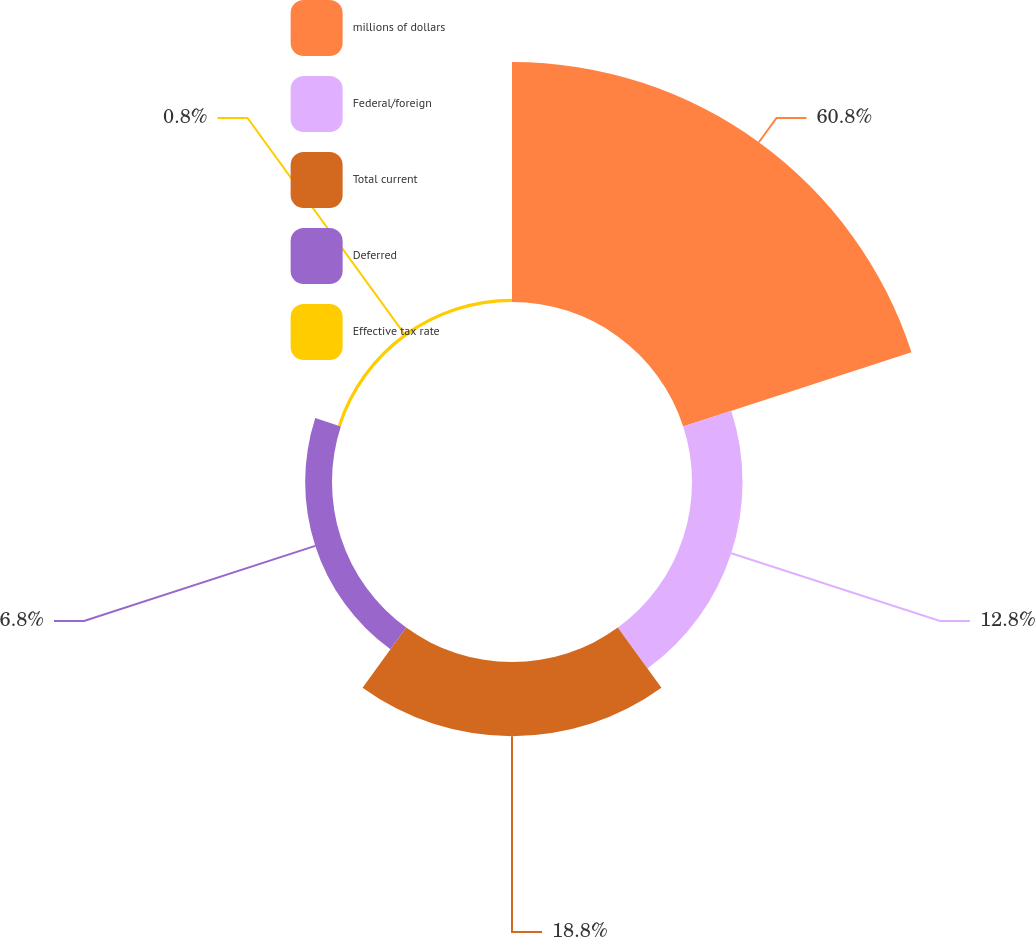Convert chart. <chart><loc_0><loc_0><loc_500><loc_500><pie_chart><fcel>millions of dollars<fcel>Federal/foreign<fcel>Total current<fcel>Deferred<fcel>Effective tax rate<nl><fcel>60.79%<fcel>12.8%<fcel>18.8%<fcel>6.8%<fcel>0.8%<nl></chart> 